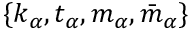Convert formula to latex. <formula><loc_0><loc_0><loc_500><loc_500>\{ k _ { \alpha } , t _ { \alpha } , m _ { \alpha } , \bar { m } _ { \alpha } \}</formula> 